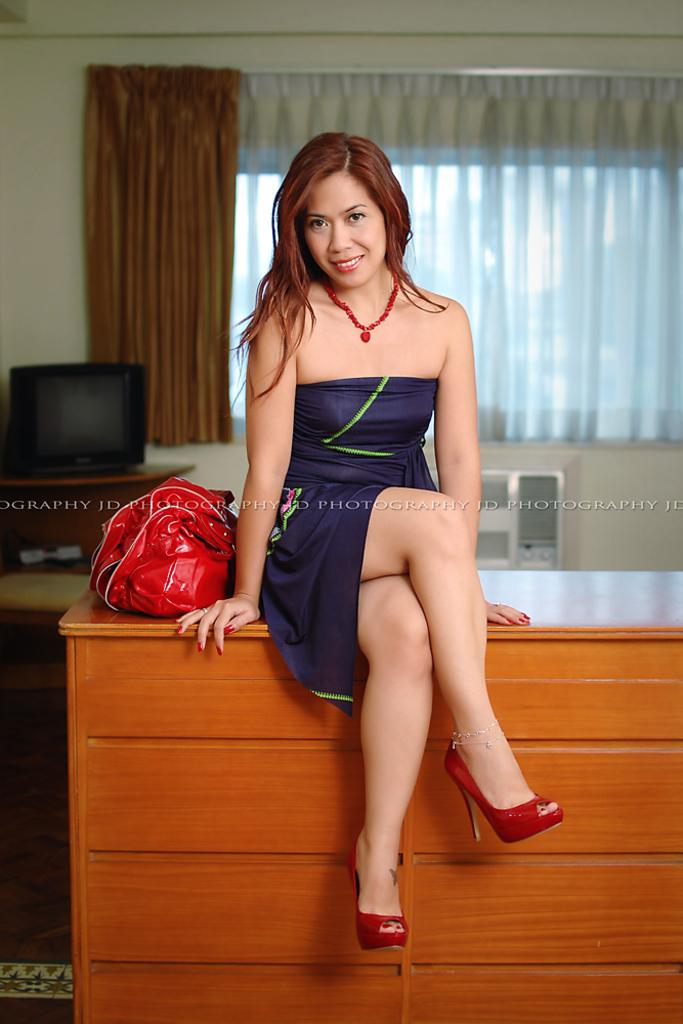What is the woman doing in the image? The woman is sitting on a table in the image. What object is beside the woman? There is a bag beside the woman. What electronic device is on the table? There is a television on the table. What can be seen in the background of the image? There is a window with curtains in the image. What type of copper material is used to make the woman's leg in the image? There is no copper material used to make the woman's leg in the image, as she is a human being and not made of copper. 